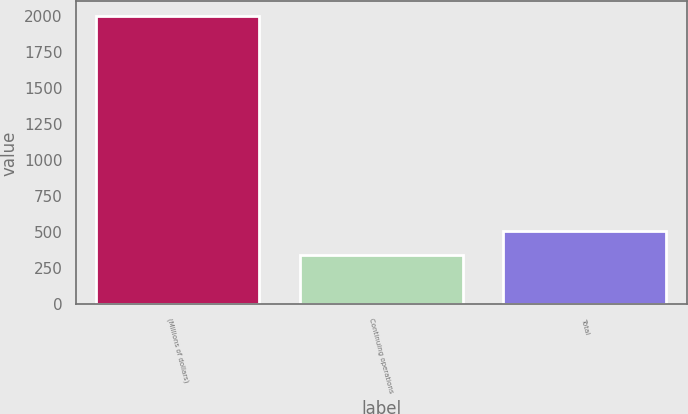<chart> <loc_0><loc_0><loc_500><loc_500><bar_chart><fcel>(Millions of dollars)<fcel>Continuing operations<fcel>Total<nl><fcel>2003<fcel>346<fcel>511.7<nl></chart> 